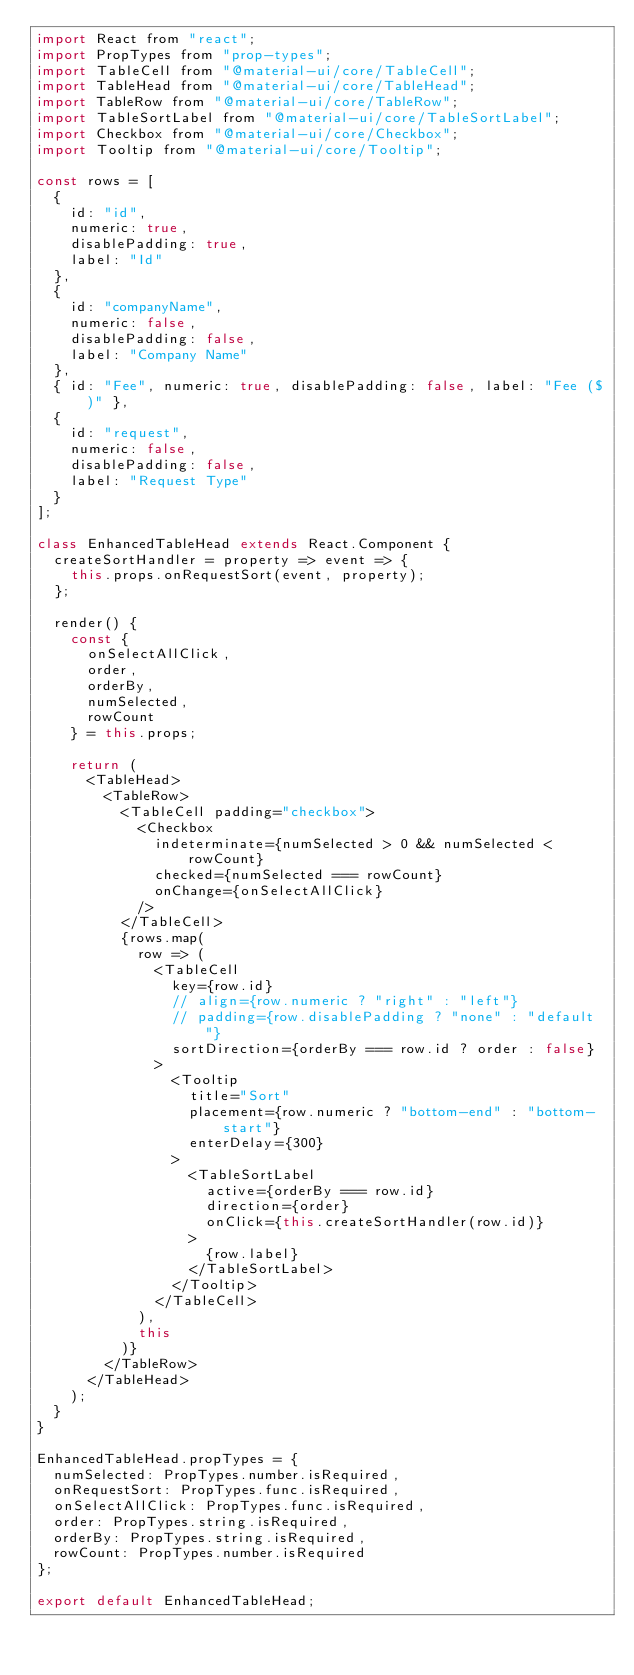Convert code to text. <code><loc_0><loc_0><loc_500><loc_500><_JavaScript_>import React from "react";
import PropTypes from "prop-types";
import TableCell from "@material-ui/core/TableCell";
import TableHead from "@material-ui/core/TableHead";
import TableRow from "@material-ui/core/TableRow";
import TableSortLabel from "@material-ui/core/TableSortLabel";
import Checkbox from "@material-ui/core/Checkbox";
import Tooltip from "@material-ui/core/Tooltip";

const rows = [
  {
    id: "id",
    numeric: true,
    disablePadding: true,
    label: "Id"
  },
  {
    id: "companyName",
    numeric: false,
    disablePadding: false,
    label: "Company Name"
  },
  { id: "Fee", numeric: true, disablePadding: false, label: "Fee ($)" },
  {
    id: "request",
    numeric: false,
    disablePadding: false,
    label: "Request Type"
  }
];

class EnhancedTableHead extends React.Component {
  createSortHandler = property => event => {
    this.props.onRequestSort(event, property);
  };

  render() {
    const {
      onSelectAllClick,
      order,
      orderBy,
      numSelected,
      rowCount
    } = this.props;

    return (
      <TableHead>
        <TableRow>
          <TableCell padding="checkbox">
            <Checkbox
              indeterminate={numSelected > 0 && numSelected < rowCount}
              checked={numSelected === rowCount}
              onChange={onSelectAllClick}
            />
          </TableCell>
          {rows.map(
            row => (
              <TableCell
                key={row.id}
                // align={row.numeric ? "right" : "left"}
                // padding={row.disablePadding ? "none" : "default"}
                sortDirection={orderBy === row.id ? order : false}
              >
                <Tooltip
                  title="Sort"
                  placement={row.numeric ? "bottom-end" : "bottom-start"}
                  enterDelay={300}
                >
                  <TableSortLabel
                    active={orderBy === row.id}
                    direction={order}
                    onClick={this.createSortHandler(row.id)}
                  >
                    {row.label}
                  </TableSortLabel>
                </Tooltip>
              </TableCell>
            ),
            this
          )}
        </TableRow>
      </TableHead>
    );
  }
}

EnhancedTableHead.propTypes = {
  numSelected: PropTypes.number.isRequired,
  onRequestSort: PropTypes.func.isRequired,
  onSelectAllClick: PropTypes.func.isRequired,
  order: PropTypes.string.isRequired,
  orderBy: PropTypes.string.isRequired,
  rowCount: PropTypes.number.isRequired
};

export default EnhancedTableHead;
</code> 